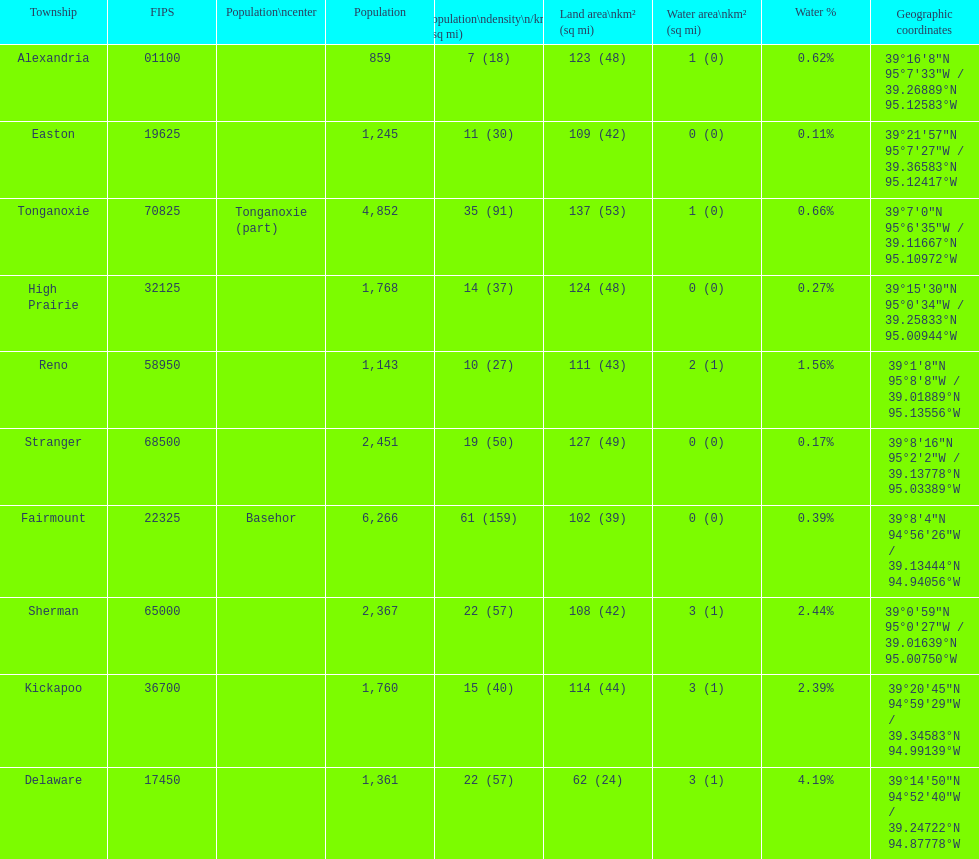Was delaware's land area above or below 45 square miles? Above. 